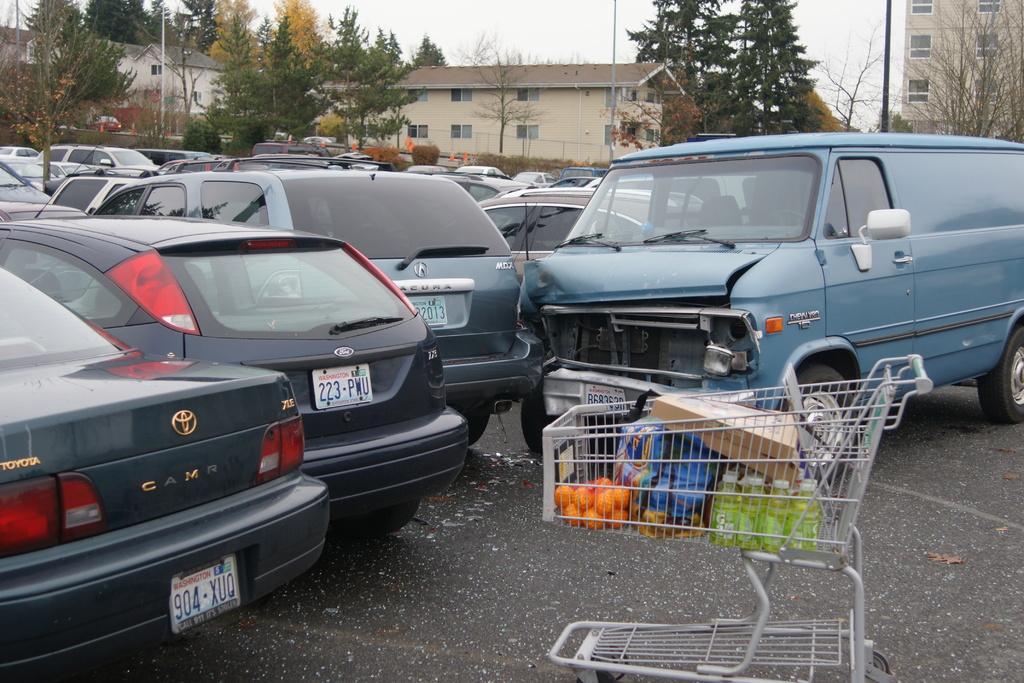How would you summarize this image in a sentence or two? In this image we can see a group of vehicles parked on the road. We can also see a trolley beside them containing some oranges, bottles and bags in it. On the backside we can see some houses with roof and windows, some traffic poles, a group of trees, plants, poles and the sky which looks cloudy. 